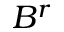<formula> <loc_0><loc_0><loc_500><loc_500>B ^ { r }</formula> 